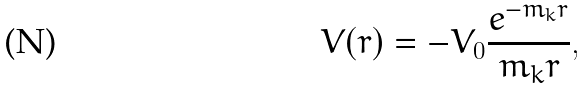Convert formula to latex. <formula><loc_0><loc_0><loc_500><loc_500>V ( r ) = - V _ { 0 } \frac { e ^ { - m _ { k } r } } { m _ { k } r } ,</formula> 